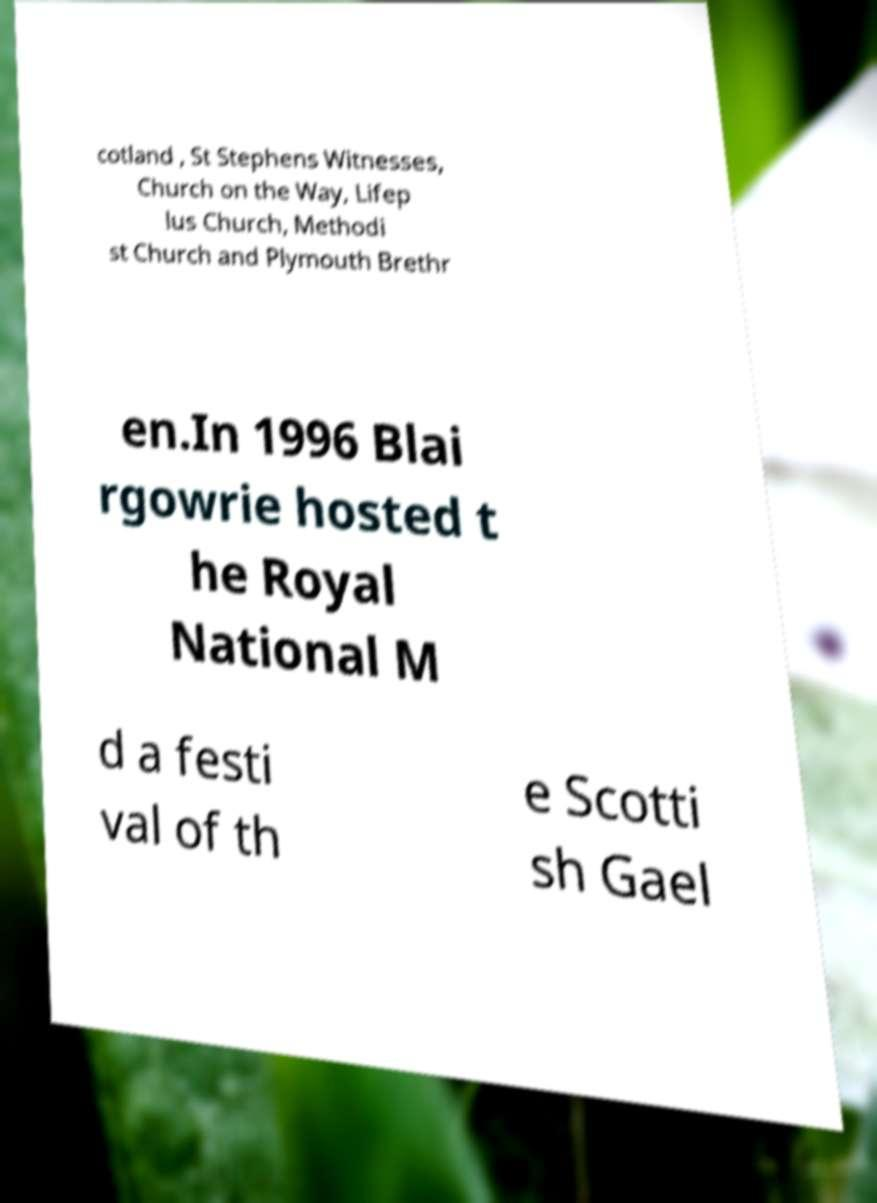Could you assist in decoding the text presented in this image and type it out clearly? cotland , St Stephens Witnesses, Church on the Way, Lifep lus Church, Methodi st Church and Plymouth Brethr en.In 1996 Blai rgowrie hosted t he Royal National M d a festi val of th e Scotti sh Gael 